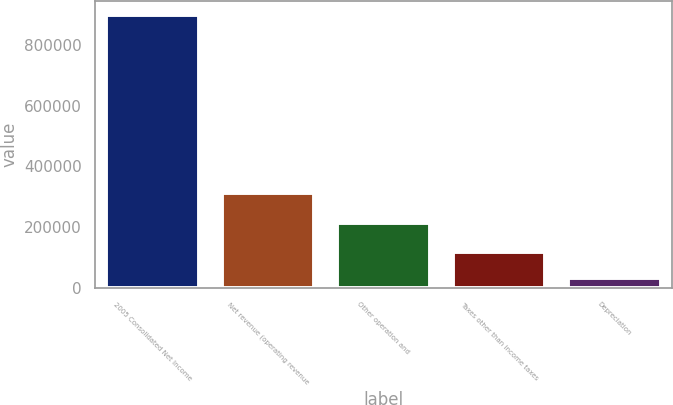<chart> <loc_0><loc_0><loc_500><loc_500><bar_chart><fcel>2005 Consolidated Net Income<fcel>Net revenue (operating revenue<fcel>Other operation and<fcel>Taxes other than income taxes<fcel>Depreciation<nl><fcel>898331<fcel>313661<fcel>213158<fcel>118107<fcel>31415<nl></chart> 